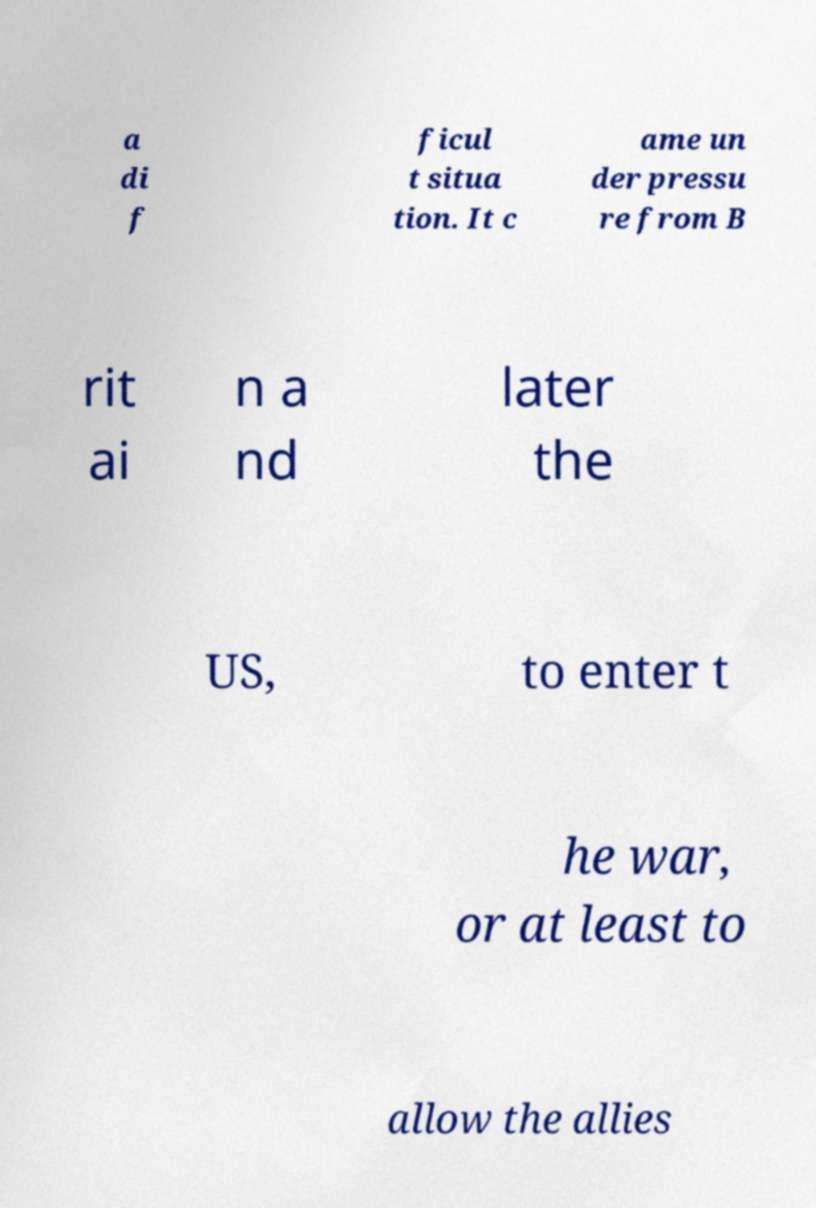Can you accurately transcribe the text from the provided image for me? a di f ficul t situa tion. It c ame un der pressu re from B rit ai n a nd later the US, to enter t he war, or at least to allow the allies 